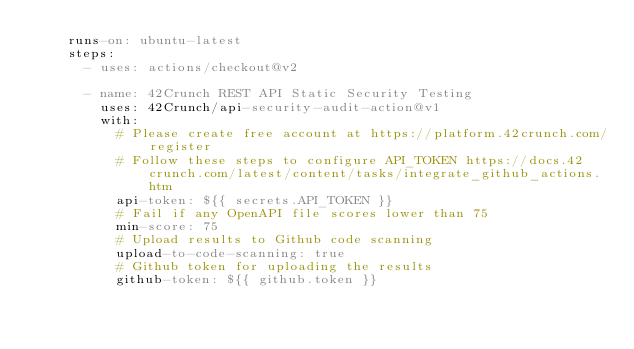<code> <loc_0><loc_0><loc_500><loc_500><_YAML_>    runs-on: ubuntu-latest
    steps:
      - uses: actions/checkout@v2

      - name: 42Crunch REST API Static Security Testing
        uses: 42Crunch/api-security-audit-action@v1
        with:
          # Please create free account at https://platform.42crunch.com/register
          # Follow these steps to configure API_TOKEN https://docs.42crunch.com/latest/content/tasks/integrate_github_actions.htm
          api-token: ${{ secrets.API_TOKEN }}
          # Fail if any OpenAPI file scores lower than 75
          min-score: 75
          # Upload results to Github code scanning
          upload-to-code-scanning: true
          # Github token for uploading the results
          github-token: ${{ github.token }}
</code> 